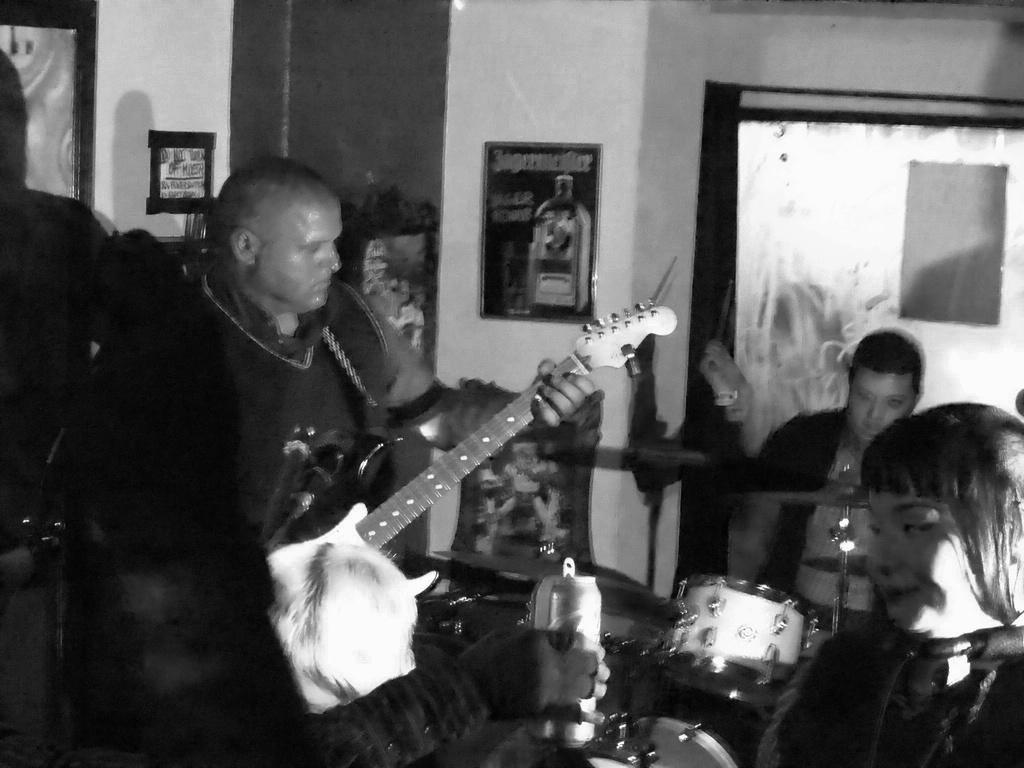What is the main activity taking place in the image? There are two men playing musical instruments in the image. What instrument is the man standing up playing? The man standing up is playing a guitar in the image. What instrument is the seated man playing? The seated man is playing drums in the image. What type of lumber is being used to fuel the fire in the image? There is no fire or lumber present in the image; it features two men playing musical instruments. 